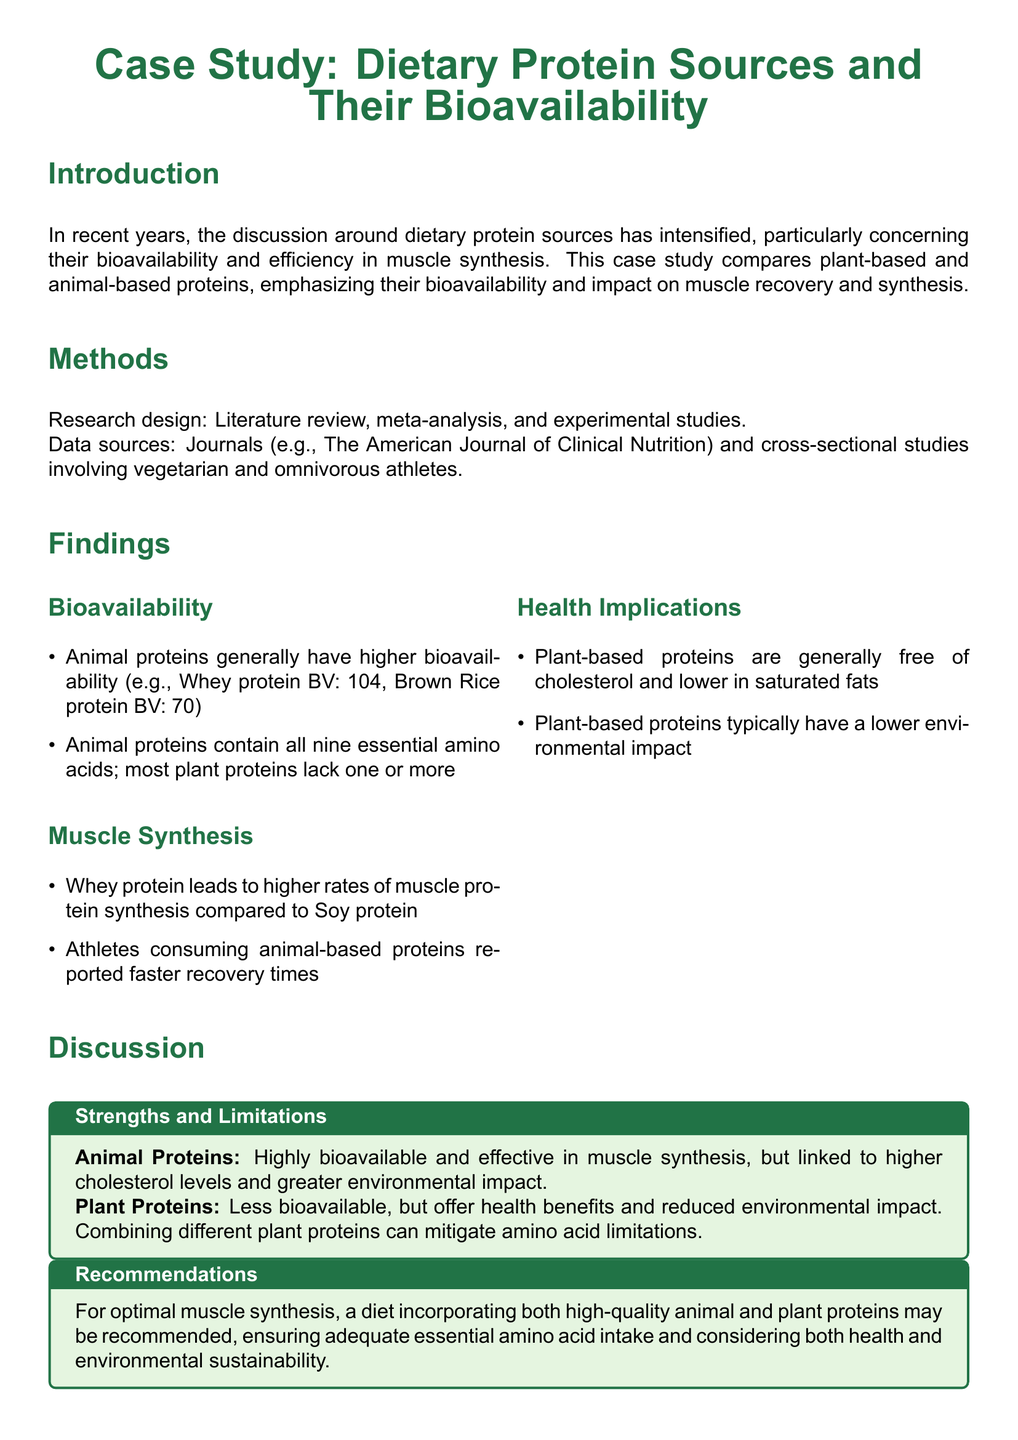What is the primary focus of the case study? The primary focus of the case study is to compare plant-based and animal-based proteins, emphasizing their bioavailability and impact on muscle recovery and synthesis.
Answer: Dietary protein sources and their bioavailability What is the bioavailability of Whey protein? The bioavailability of Whey protein is noted as 104, indicating a high efficiency in muscle synthesis.
Answer: 104 What are the two data sources mentioned in the methods? The data sources listed in the methods include journals and cross-sectional studies.
Answer: Journals and cross-sectional studies Which protein leads to higher rates of muscle protein synthesis? The case study indicates that Whey protein leads to higher rates of muscle protein synthesis compared to Soy protein.
Answer: Whey protein What health benefit is noted for plant-based proteins? The health benefit mentioned for plant-based proteins is that they are generally free of cholesterol.
Answer: Free of cholesterol What is one limitation of animal proteins? One limitation mentioned for animal proteins is their link to higher cholesterol levels.
Answer: Higher cholesterol levels What is a recommended dietary approach for optimal muscle synthesis? The recommendation for optimal muscle synthesis is to incorporate both high-quality animal and plant proteins.
Answer: Incorporate both animal and plant proteins What essential amino acids issue is noted with most plant proteins? It is noted that most plant proteins lack one or more of the nine essential amino acids.
Answer: Lack one or more essential amino acids What is a noted environmental impact of plant-based proteins? Plant-based proteins typically have a lower environmental impact compared to animal proteins.
Answer: Lower environmental impact 